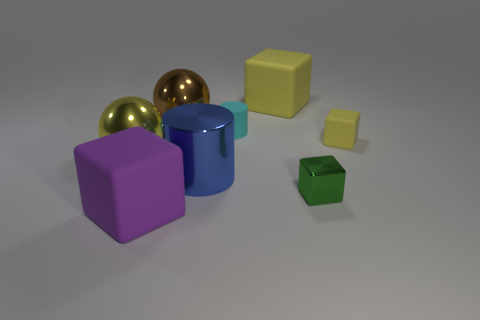Add 1 large red matte things. How many objects exist? 9 Subtract all purple matte blocks. How many blocks are left? 3 Subtract all cylinders. How many objects are left? 6 Subtract 2 blocks. How many blocks are left? 2 Add 4 blocks. How many blocks are left? 8 Add 7 cyan matte things. How many cyan matte things exist? 8 Subtract all yellow blocks. How many blocks are left? 2 Subtract 0 gray cylinders. How many objects are left? 8 Subtract all brown cylinders. Subtract all gray spheres. How many cylinders are left? 2 Subtract all red cubes. How many green balls are left? 0 